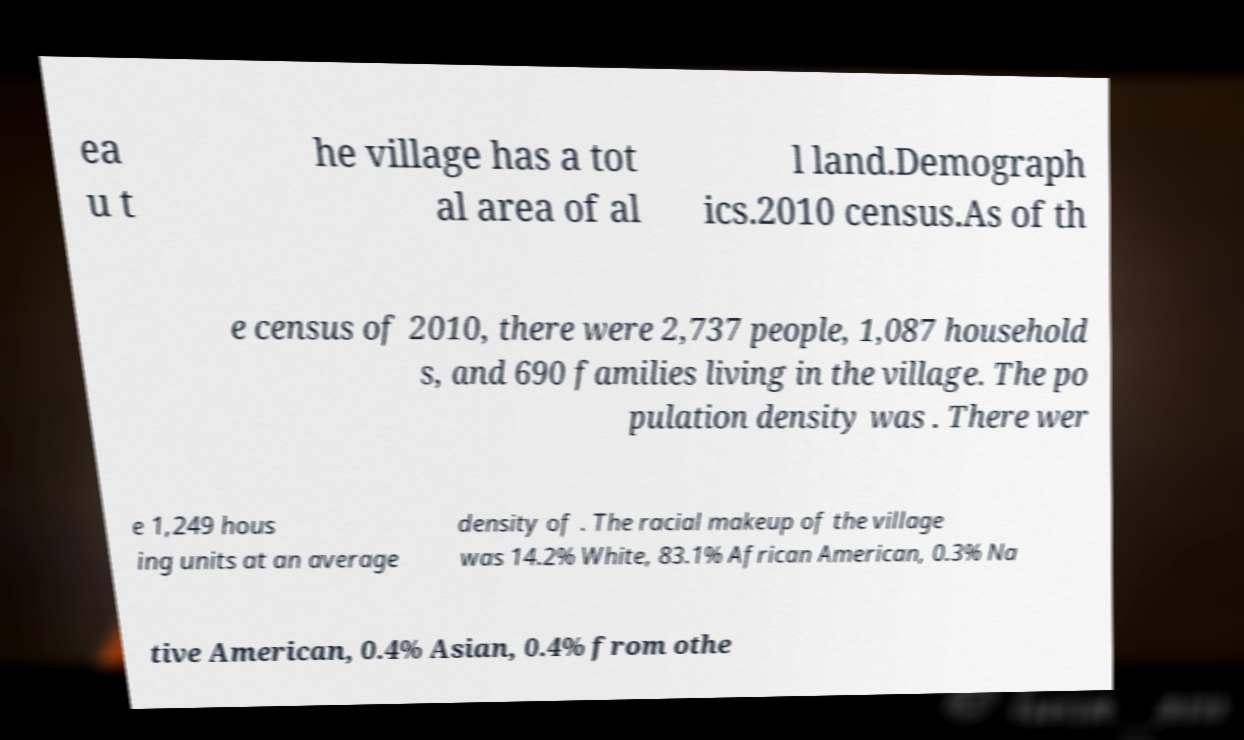Please read and relay the text visible in this image. What does it say? ea u t he village has a tot al area of al l land.Demograph ics.2010 census.As of th e census of 2010, there were 2,737 people, 1,087 household s, and 690 families living in the village. The po pulation density was . There wer e 1,249 hous ing units at an average density of . The racial makeup of the village was 14.2% White, 83.1% African American, 0.3% Na tive American, 0.4% Asian, 0.4% from othe 